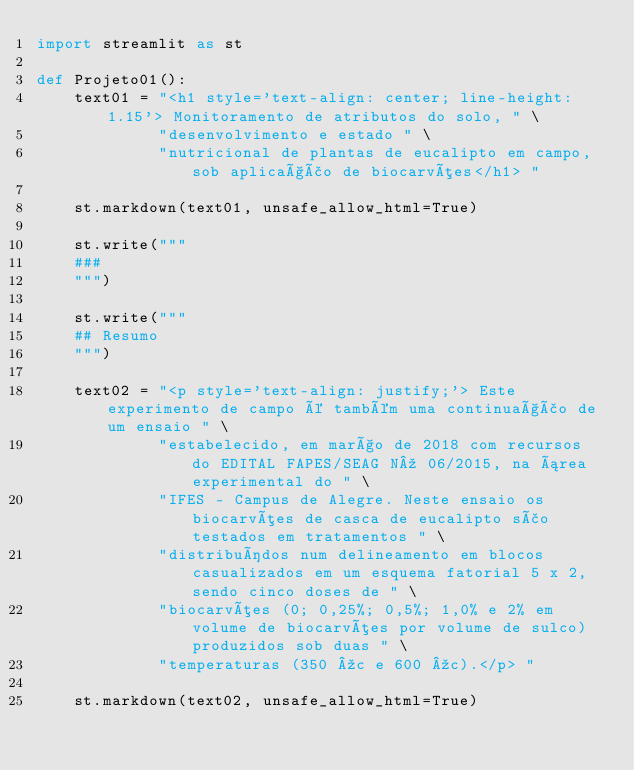<code> <loc_0><loc_0><loc_500><loc_500><_Python_>import streamlit as st

def Projeto01():
    text01 = "<h1 style='text-align: center; line-height: 1.15'> Monitoramento de atributos do solo, " \
             "desenvolvimento e estado " \
             "nutricional de plantas de eucalipto em campo, sob aplicação de biocarvões</h1> "

    st.markdown(text01, unsafe_allow_html=True)

    st.write("""
    ###  
    """)

    st.write("""
    ## Resumo
    """)

    text02 = "<p style='text-align: justify;'> Este experimento de campo é também uma continuação de um ensaio " \
             "estabelecido, em março de 2018 com recursos do EDITAL FAPES/SEAG Nº 06/2015, na área experimental do " \
             "IFES - Campus de Alegre. Neste ensaio os biocarvões de casca de eucalipto são testados em tratamentos " \
             "distribuídos num delineamento em blocos casualizados em um esquema fatorial 5 x 2, sendo cinco doses de " \
             "biocarvões (0; 0,25%; 0,5%; 1,0% e 2% em volume de biocarvões por volume de sulco) produzidos sob duas " \
             "temperaturas (350 ºc e 600 ºc).</p> "

    st.markdown(text02, unsafe_allow_html=True)

</code> 